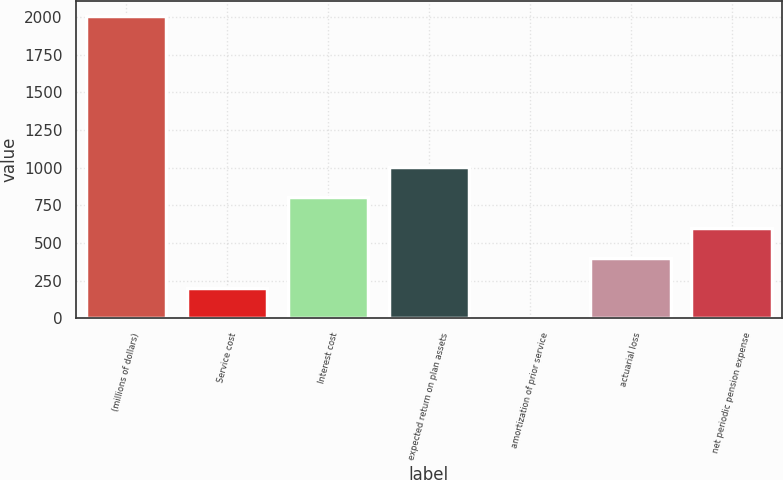Convert chart to OTSL. <chart><loc_0><loc_0><loc_500><loc_500><bar_chart><fcel>(millions of dollars)<fcel>Service cost<fcel>Interest cost<fcel>expected return on plan assets<fcel>amortization of prior service<fcel>actuarial loss<fcel>net periodic pension expense<nl><fcel>2007<fcel>200.79<fcel>802.86<fcel>1003.55<fcel>0.1<fcel>401.48<fcel>602.17<nl></chart> 